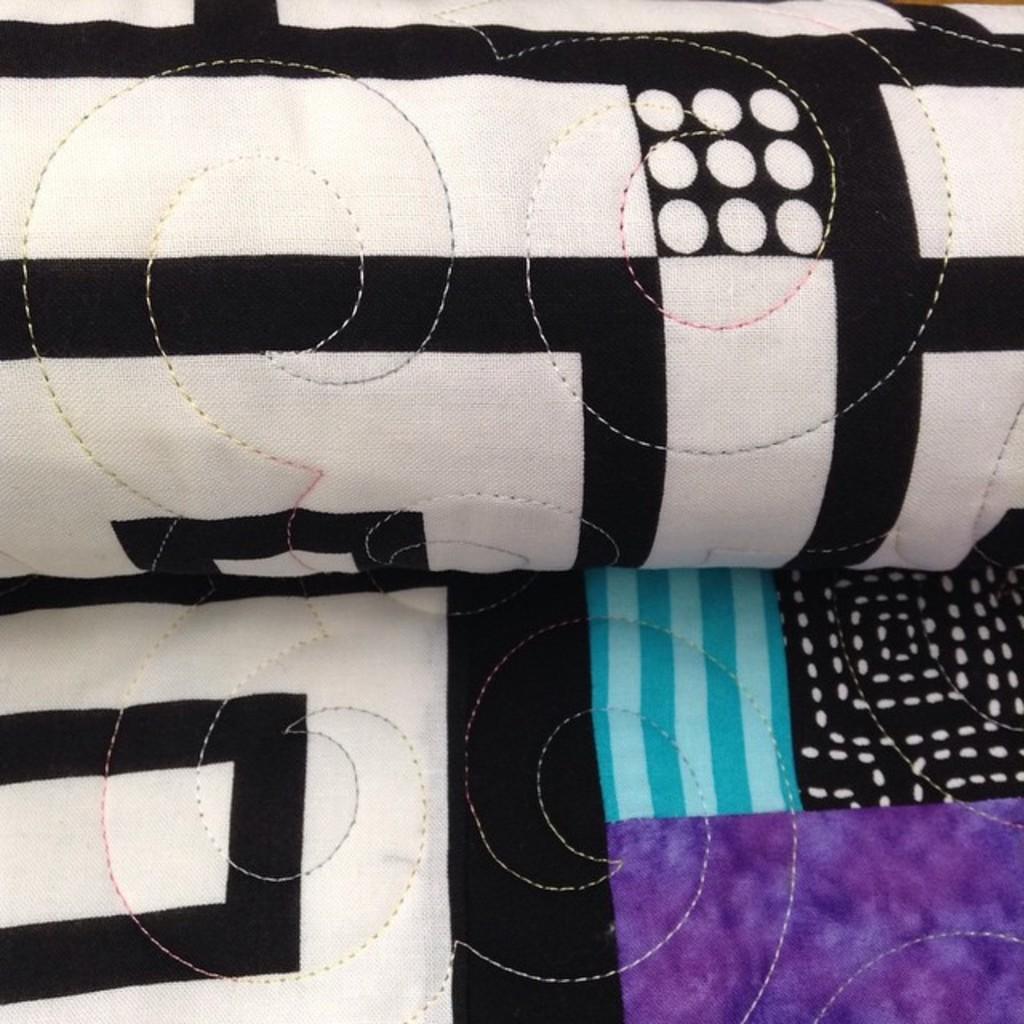Could you give a brief overview of what you see in this image? In this image we can see cloth of different colors. 